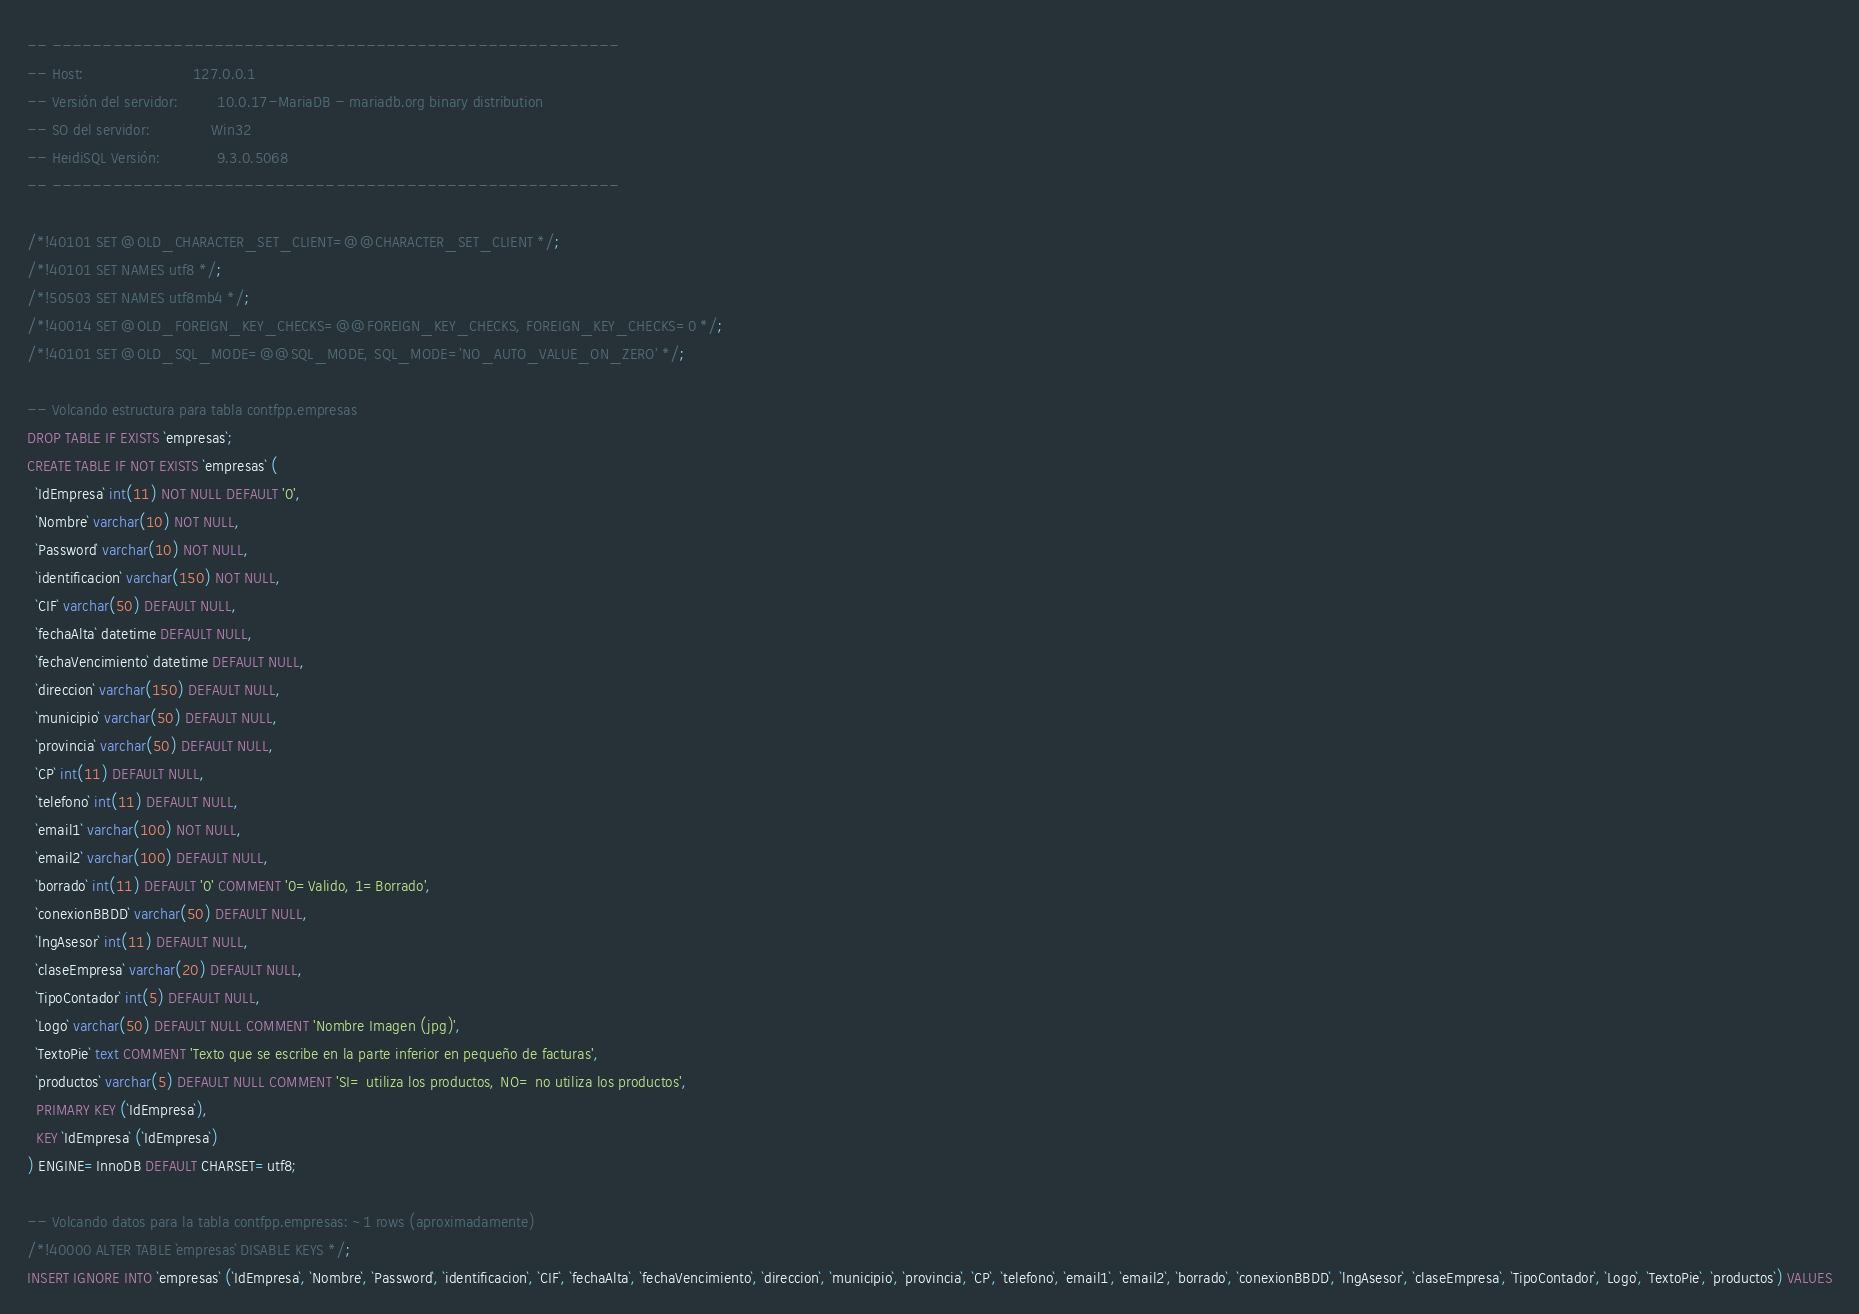Convert code to text. <code><loc_0><loc_0><loc_500><loc_500><_SQL_>-- --------------------------------------------------------
-- Host:                         127.0.0.1
-- Versión del servidor:         10.0.17-MariaDB - mariadb.org binary distribution
-- SO del servidor:              Win32
-- HeidiSQL Versión:             9.3.0.5068
-- --------------------------------------------------------

/*!40101 SET @OLD_CHARACTER_SET_CLIENT=@@CHARACTER_SET_CLIENT */;
/*!40101 SET NAMES utf8 */;
/*!50503 SET NAMES utf8mb4 */;
/*!40014 SET @OLD_FOREIGN_KEY_CHECKS=@@FOREIGN_KEY_CHECKS, FOREIGN_KEY_CHECKS=0 */;
/*!40101 SET @OLD_SQL_MODE=@@SQL_MODE, SQL_MODE='NO_AUTO_VALUE_ON_ZERO' */;

-- Volcando estructura para tabla contfpp.empresas
DROP TABLE IF EXISTS `empresas`;
CREATE TABLE IF NOT EXISTS `empresas` (
  `IdEmpresa` int(11) NOT NULL DEFAULT '0',
  `Nombre` varchar(10) NOT NULL,
  `Password` varchar(10) NOT NULL,
  `identificacion` varchar(150) NOT NULL,
  `CIF` varchar(50) DEFAULT NULL,
  `fechaAlta` datetime DEFAULT NULL,
  `fechaVencimiento` datetime DEFAULT NULL,
  `direccion` varchar(150) DEFAULT NULL,
  `municipio` varchar(50) DEFAULT NULL,
  `provincia` varchar(50) DEFAULT NULL,
  `CP` int(11) DEFAULT NULL,
  `telefono` int(11) DEFAULT NULL,
  `email1` varchar(100) NOT NULL,
  `email2` varchar(100) DEFAULT NULL,
  `borrado` int(11) DEFAULT '0' COMMENT '0=Valido, 1=Borrado',
  `conexionBBDD` varchar(50) DEFAULT NULL,
  `lngAsesor` int(11) DEFAULT NULL,
  `claseEmpresa` varchar(20) DEFAULT NULL,
  `TipoContador` int(5) DEFAULT NULL,
  `Logo` varchar(50) DEFAULT NULL COMMENT 'Nombre Imagen (jpg)',
  `TextoPie` text COMMENT 'Texto que se escribe en la parte inferior en pequeño de facturas',
  `productos` varchar(5) DEFAULT NULL COMMENT 'SI= utiliza los productos, NO= no utiliza los productos',
  PRIMARY KEY (`IdEmpresa`),
  KEY `IdEmpresa` (`IdEmpresa`)
) ENGINE=InnoDB DEFAULT CHARSET=utf8;

-- Volcando datos para la tabla contfpp.empresas: ~1 rows (aproximadamente)
/*!40000 ALTER TABLE `empresas` DISABLE KEYS */;
INSERT IGNORE INTO `empresas` (`IdEmpresa`, `Nombre`, `Password`, `identificacion`, `CIF`, `fechaAlta`, `fechaVencimiento`, `direccion`, `municipio`, `provincia`, `CP`, `telefono`, `email1`, `email2`, `borrado`, `conexionBBDD`, `lngAsesor`, `claseEmpresa`, `TipoContador`, `Logo`, `TextoPie`, `productos`) VALUES</code> 